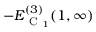<formula> <loc_0><loc_0><loc_500><loc_500>- E _ { C _ { 1 } } ^ { ( 3 ) } ( 1 , \infty )</formula> 